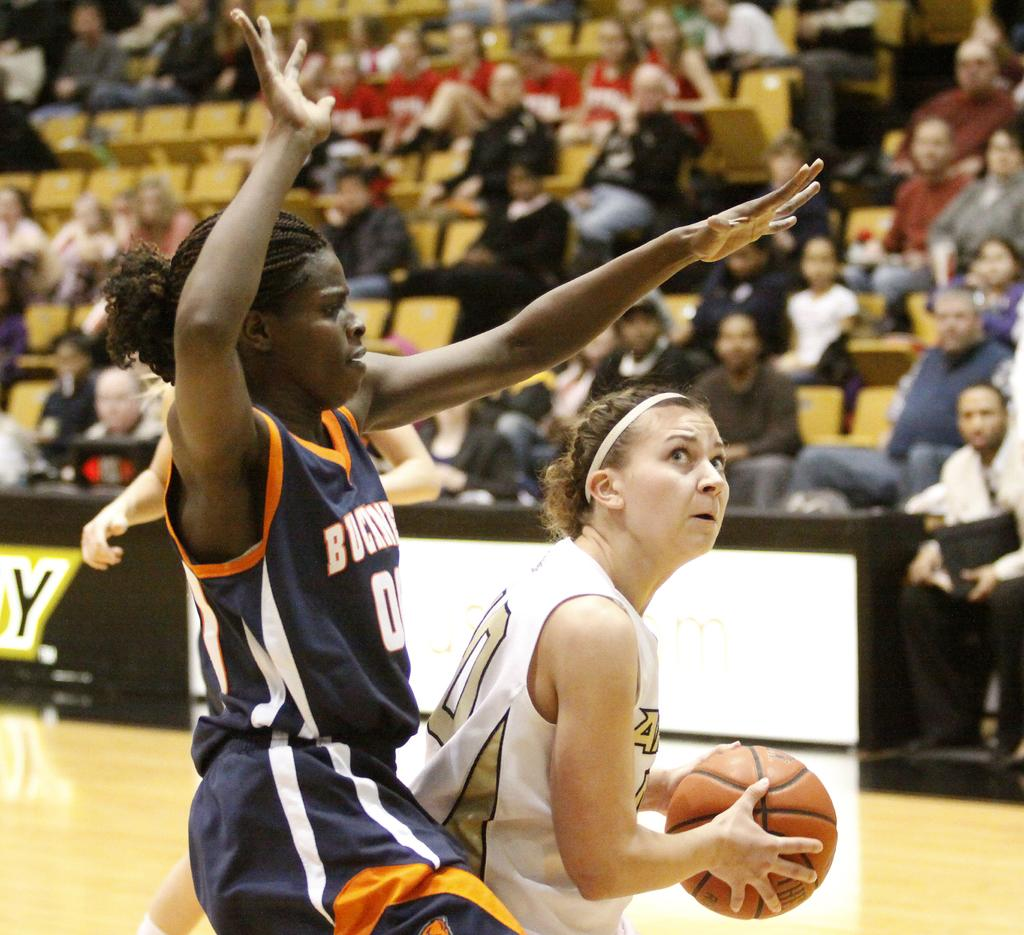What are the two women in the image doing? The two women in the image are playing basketball. Which of the women is holding a ball? One of the women is holding a ball. What can be seen in the background of the image? There are people sitting on chairs in the background of the image. What type of dress is the woman wearing while holding the gun in the image? There is no woman holding a gun in the image; the women are playing basketball. 